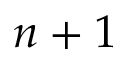<formula> <loc_0><loc_0><loc_500><loc_500>n + 1</formula> 